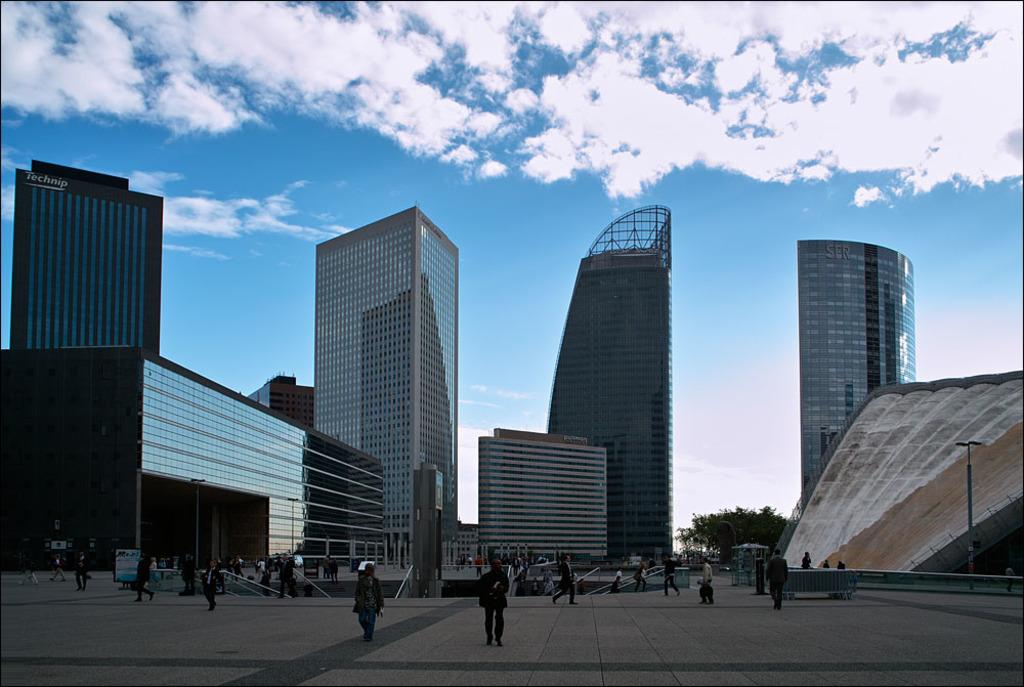What type of structures can be seen in the image? There are buildings in the image. What are the people in the image doing? There are people walking on the land in the image. What type of vegetation is present in the image? There are trees in the image. What can be seen in the background of the image? The sky is visible in the background of the image, and there are clouds in the sky. What type of net is being used by the people walking on the land in the image? There is no net present in the image; people are simply walking on the land. What credit card company is sponsoring the holiday depicted in the image? There is no holiday depicted in the image, and no credit card company is mentioned or implied. 